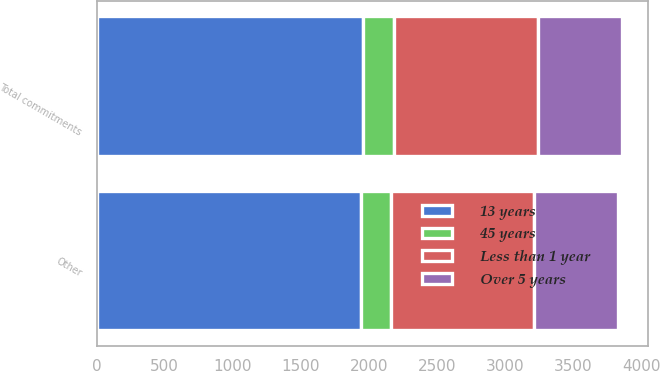Convert chart to OTSL. <chart><loc_0><loc_0><loc_500><loc_500><stacked_bar_chart><ecel><fcel>Other<fcel>Total commitments<nl><fcel>13 years<fcel>1945<fcel>1958<nl><fcel>45 years<fcel>216<fcel>227<nl><fcel>Less than 1 year<fcel>1052<fcel>1054<nl><fcel>Over 5 years<fcel>616<fcel>616<nl></chart> 